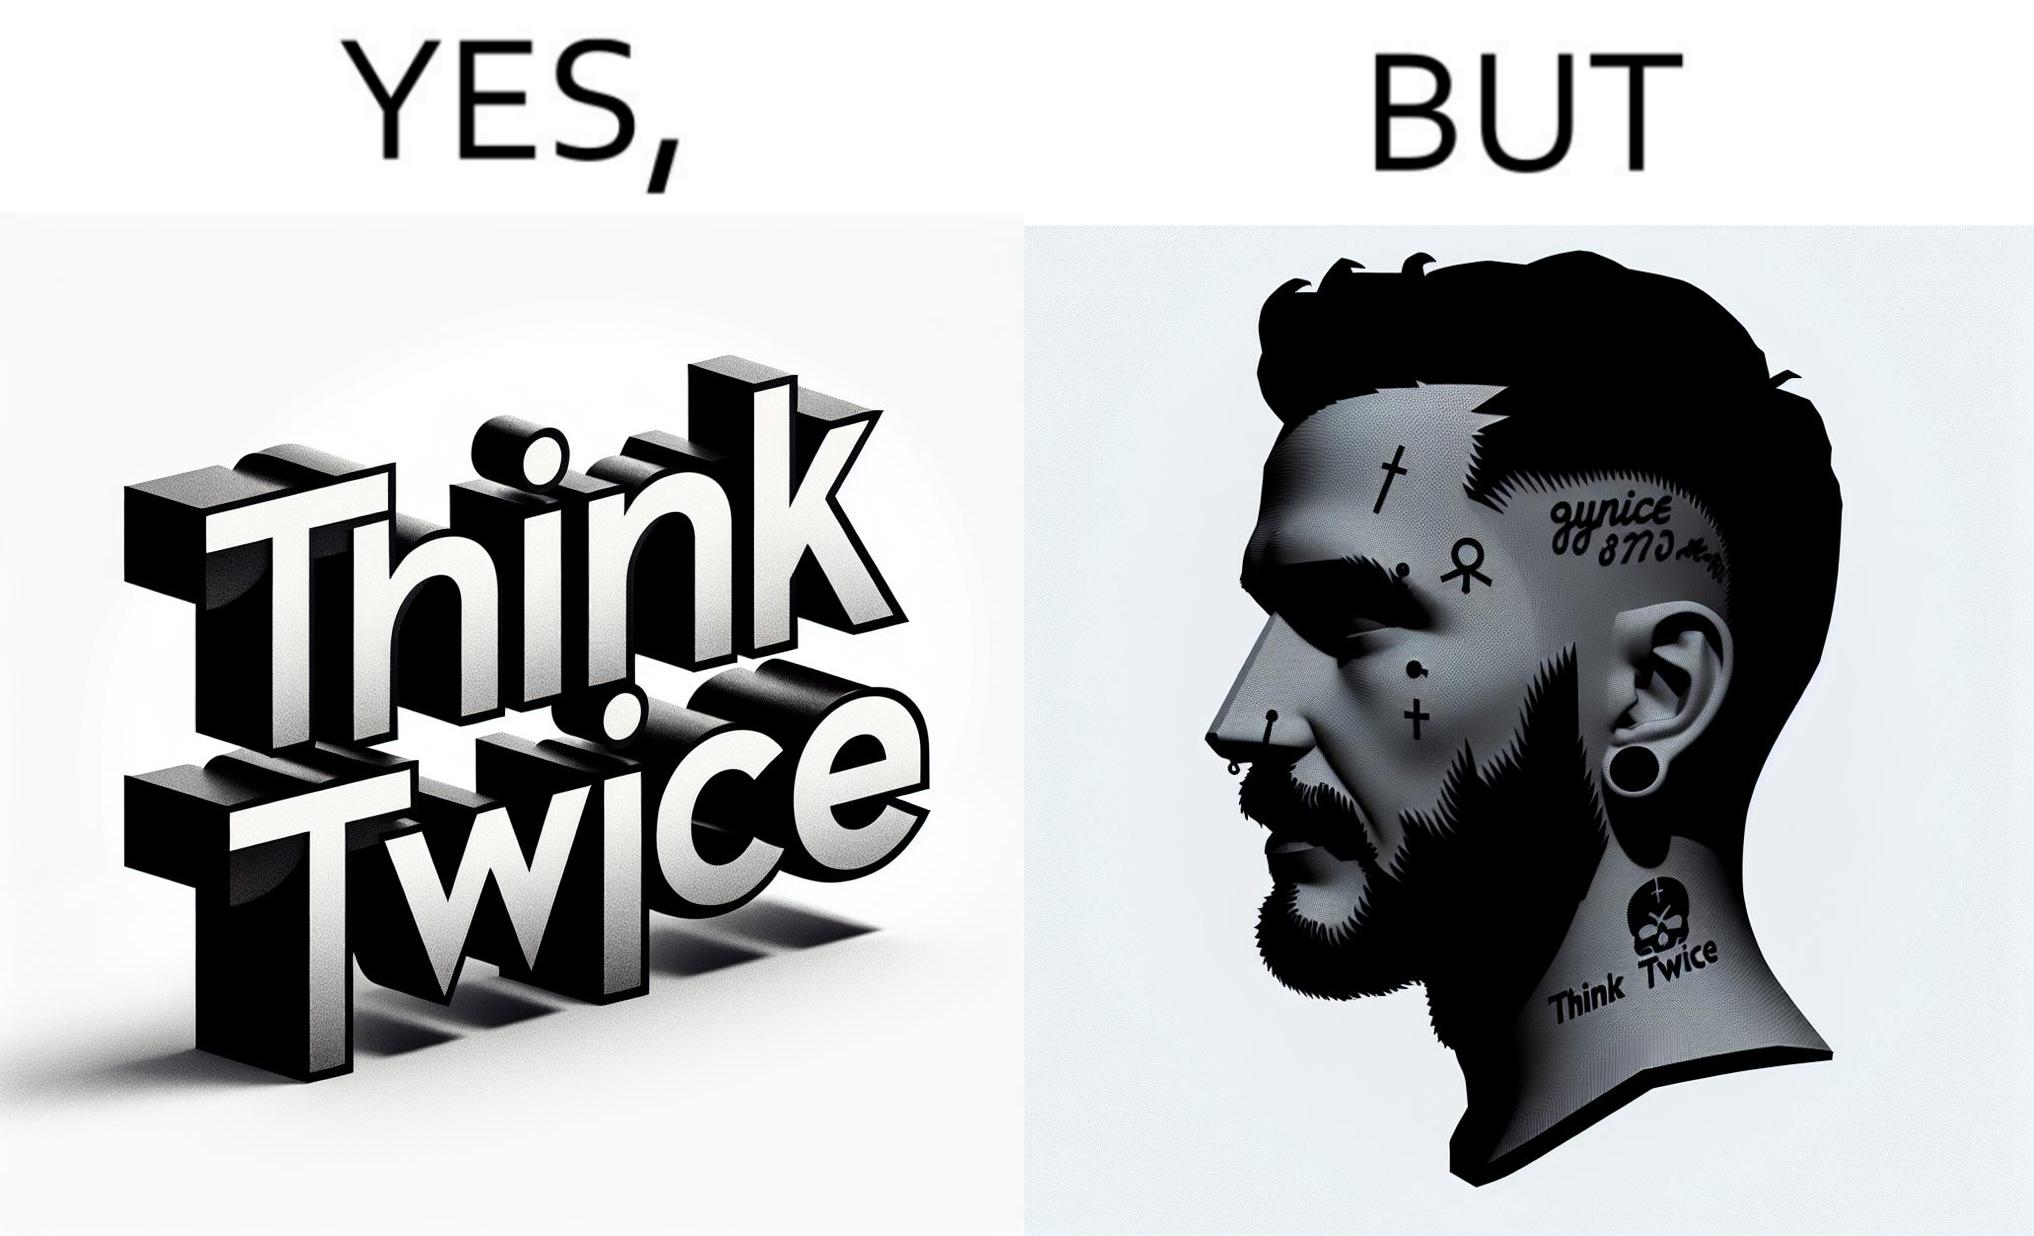What is the satirical meaning behind this image? The image is funny because even thought the tattoo on the face of the man says "think twice", the man did not think twice before getting the tattoo on his forehead. 